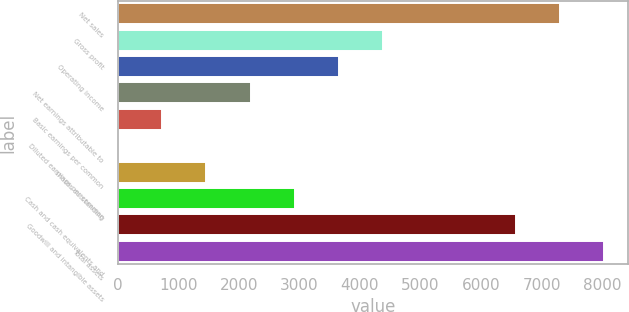<chart> <loc_0><loc_0><loc_500><loc_500><bar_chart><fcel>Net sales<fcel>Gross profit<fcel>Operating income<fcel>Net earnings attributable to<fcel>Basic earnings per common<fcel>Diluted earnings per common<fcel>shares outstanding<fcel>Cash and cash equivalents and<fcel>Goodwill and intangible assets<fcel>Total assets<nl><fcel>7301.81<fcel>4383.45<fcel>3653.86<fcel>2194.68<fcel>735.5<fcel>5.91<fcel>1465.09<fcel>2924.27<fcel>6572.22<fcel>8031.4<nl></chart> 